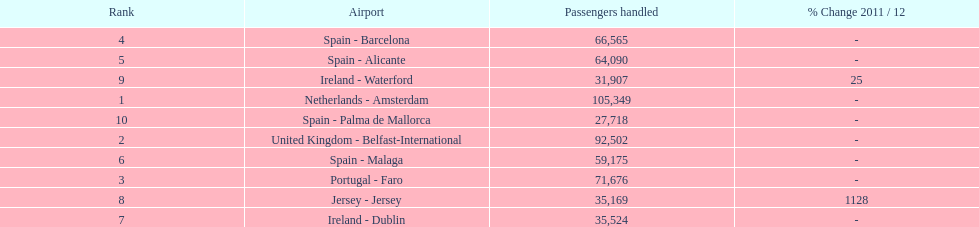Looking at the top 10 busiest routes to and from london southend airport what is the average number of passengers handled? 58,967.5. 